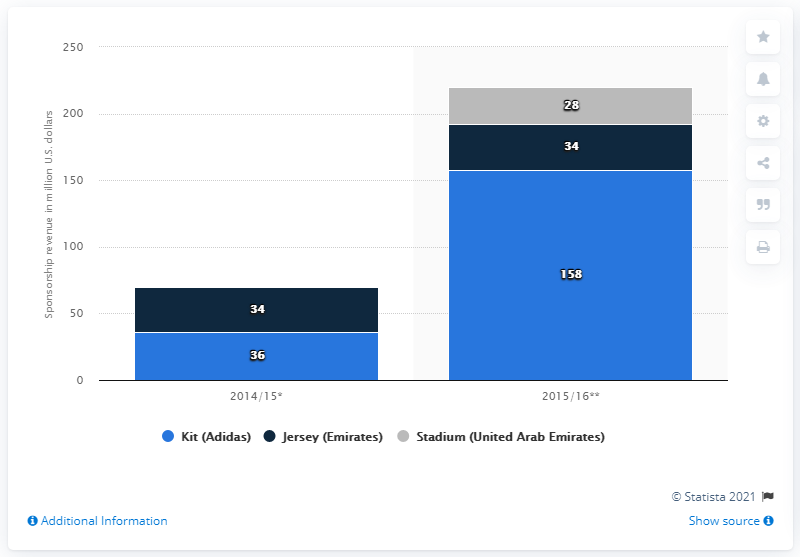Outline some significant characteristics in this image. In the 2014/15 season, the kit sponsorship revenue of Real Madrid was approximately 36... The kit in the 2014/15 and 2015/16 seasons differed in several aspects. In 2014/15, Real Madrid's kit sponsorship revenue was 36... The color grey in the context of the stadium in the United Arab Emirates indicates the presence of a stadium. 